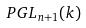<formula> <loc_0><loc_0><loc_500><loc_500>P G L _ { n + 1 } ( k )</formula> 